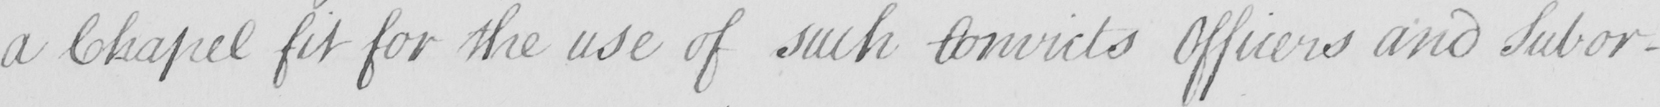Please transcribe the handwritten text in this image. a Chapel fit for the use of such Convicts Officers and Subor- 